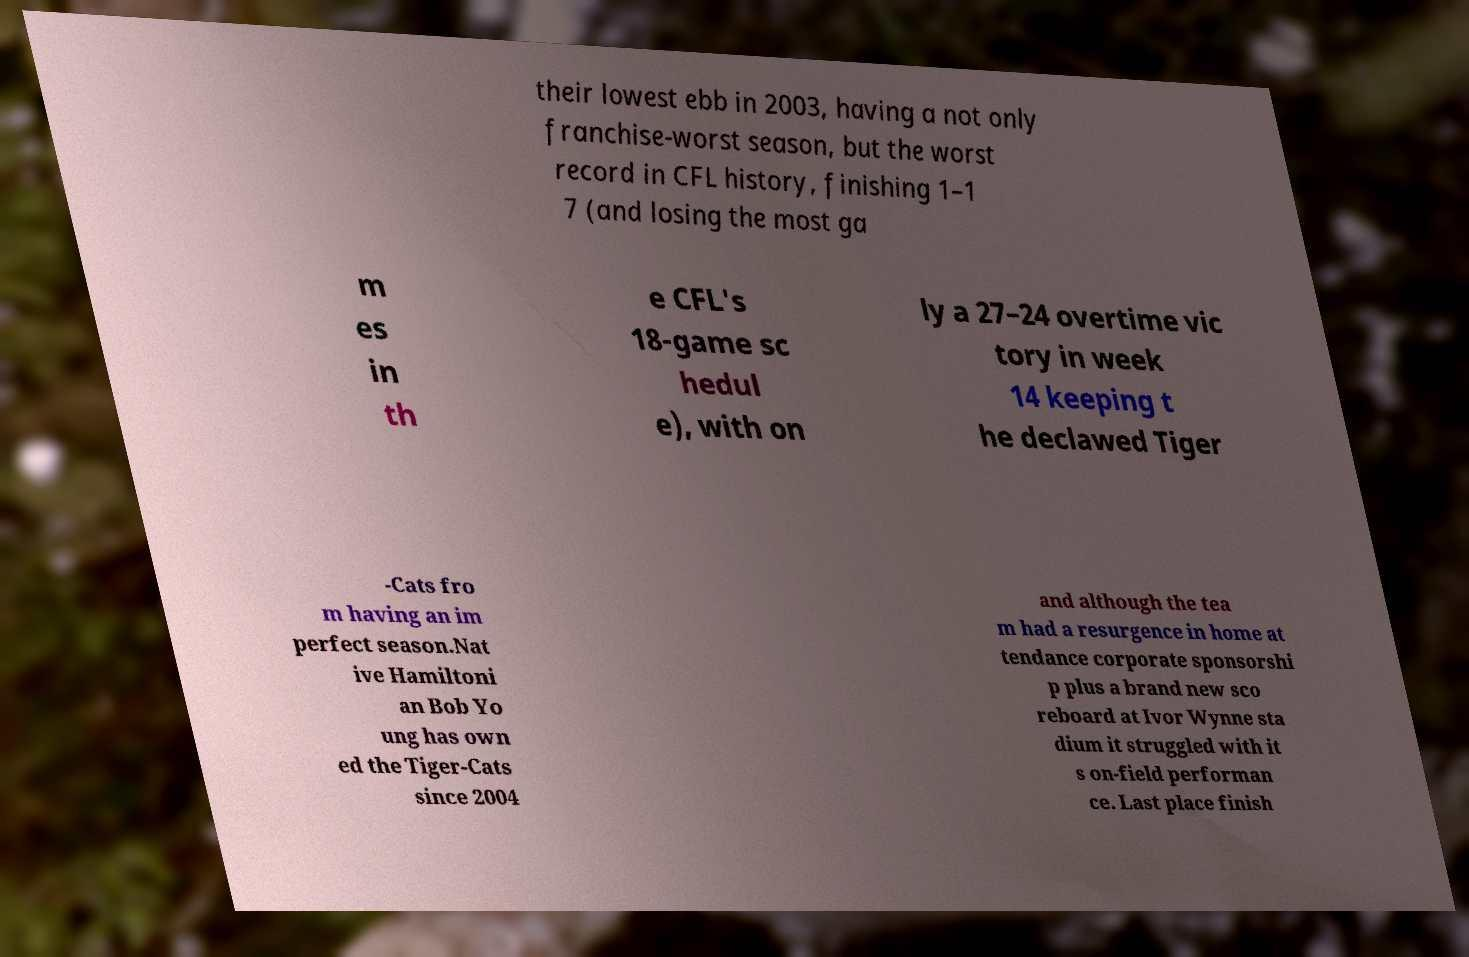I need the written content from this picture converted into text. Can you do that? their lowest ebb in 2003, having a not only franchise-worst season, but the worst record in CFL history, finishing 1–1 7 (and losing the most ga m es in th e CFL's 18-game sc hedul e), with on ly a 27–24 overtime vic tory in week 14 keeping t he declawed Tiger -Cats fro m having an im perfect season.Nat ive Hamiltoni an Bob Yo ung has own ed the Tiger-Cats since 2004 and although the tea m had a resurgence in home at tendance corporate sponsorshi p plus a brand new sco reboard at Ivor Wynne sta dium it struggled with it s on-field performan ce. Last place finish 